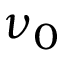Convert formula to latex. <formula><loc_0><loc_0><loc_500><loc_500>\nu _ { 0 }</formula> 